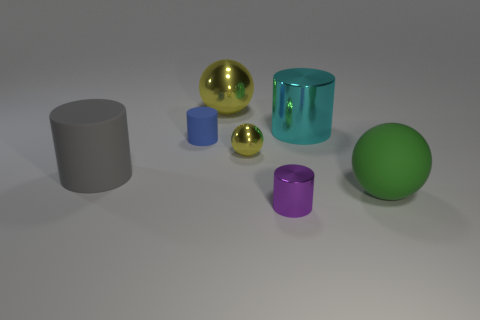What number of other objects are the same color as the tiny shiny ball?
Your answer should be compact. 1. Does the rubber thing that is on the right side of the blue matte object have the same size as the large gray matte thing?
Ensure brevity in your answer.  Yes. There is a small metallic sphere; how many metallic cylinders are in front of it?
Provide a short and direct response. 1. Is there a cylinder of the same size as the gray matte object?
Ensure brevity in your answer.  Yes. Does the large rubber ball have the same color as the big metallic cylinder?
Your answer should be compact. No. The tiny cylinder that is right of the big sphere that is to the left of the large shiny cylinder is what color?
Make the answer very short. Purple. What number of rubber objects are both behind the gray matte object and left of the tiny rubber cylinder?
Ensure brevity in your answer.  0. What number of large rubber objects are the same shape as the large cyan metallic object?
Provide a short and direct response. 1. Does the small purple cylinder have the same material as the large green object?
Your answer should be compact. No. What shape is the thing that is in front of the matte object that is to the right of the purple shiny object?
Your answer should be compact. Cylinder. 